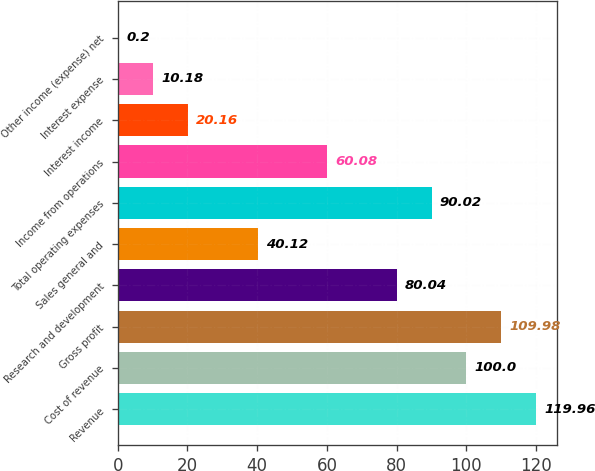<chart> <loc_0><loc_0><loc_500><loc_500><bar_chart><fcel>Revenue<fcel>Cost of revenue<fcel>Gross profit<fcel>Research and development<fcel>Sales general and<fcel>Total operating expenses<fcel>Income from operations<fcel>Interest income<fcel>Interest expense<fcel>Other income (expense) net<nl><fcel>119.96<fcel>100<fcel>109.98<fcel>80.04<fcel>40.12<fcel>90.02<fcel>60.08<fcel>20.16<fcel>10.18<fcel>0.2<nl></chart> 